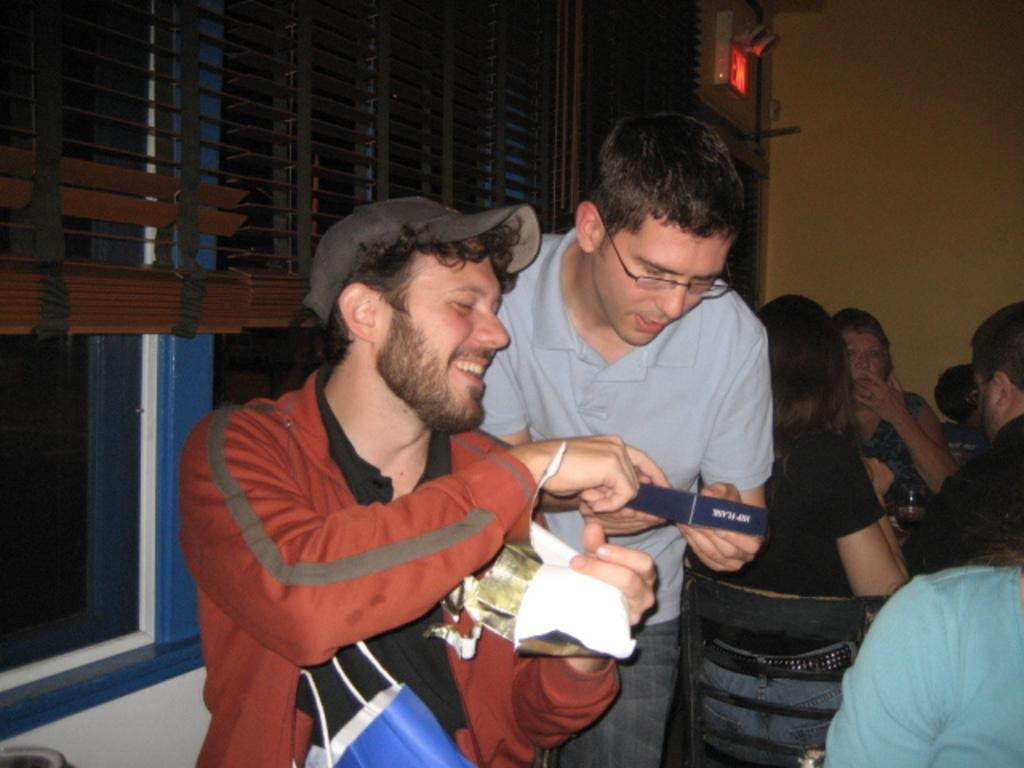How many people are in the foreground of the image? There are two persons in the foreground of the image. What is visible behind the persons? There is a window visible behind the persons. What is on the right side of the image? There is a wall on the right side of the image. What are the people in the image doing? There are people sitting on chairs in the image. What type of grain can be seen growing in the image? There is no grain visible in the image; it features two persons and a window in the background. 